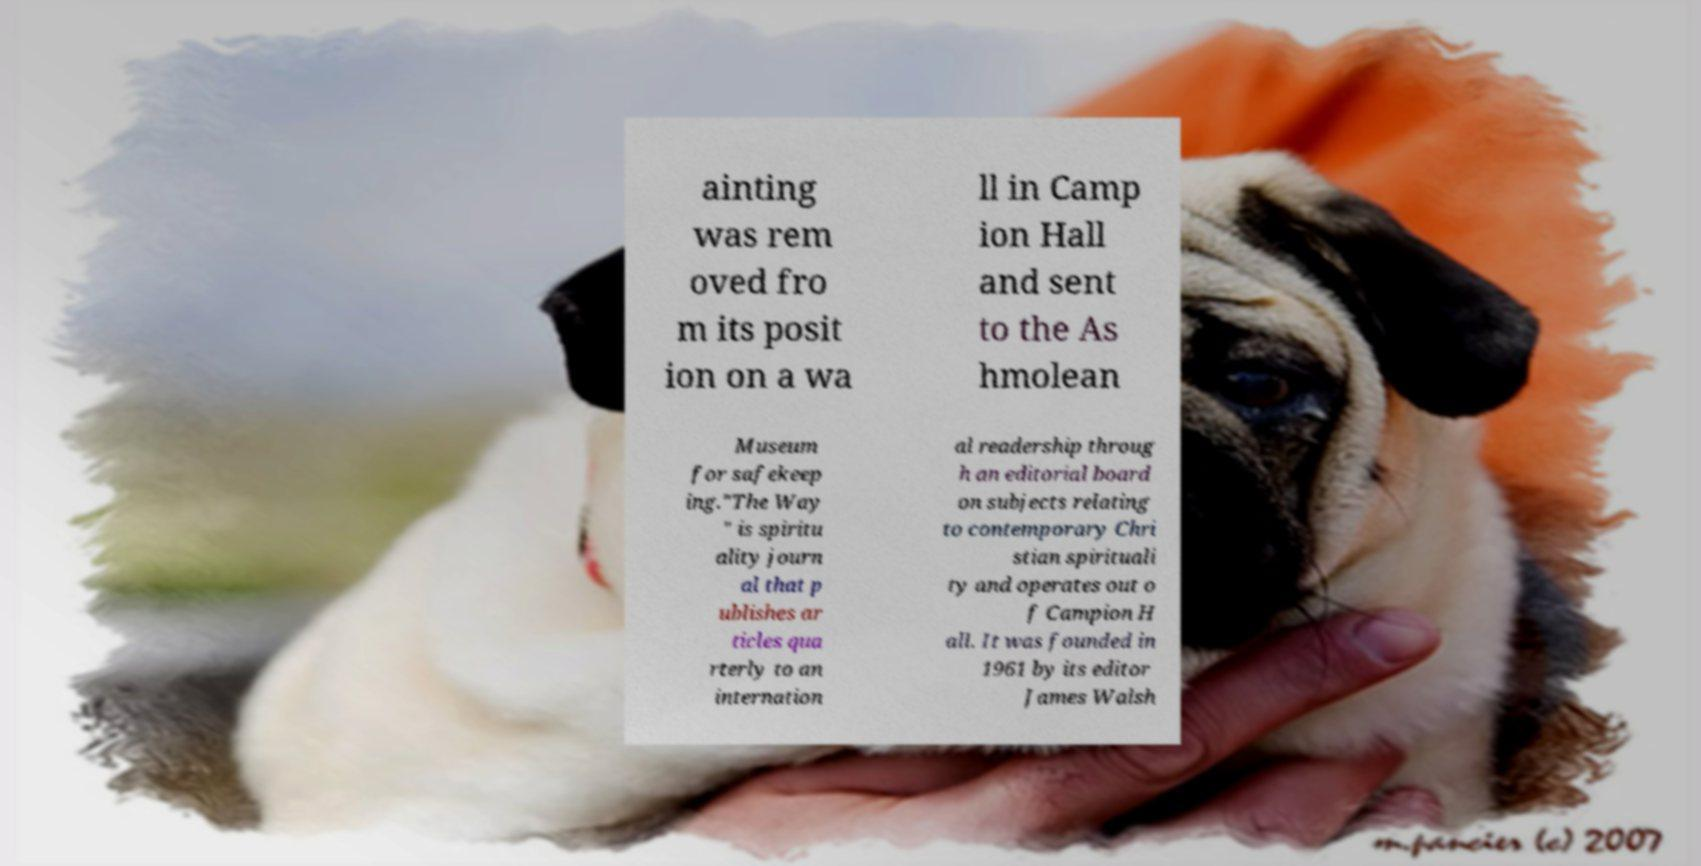Could you assist in decoding the text presented in this image and type it out clearly? ainting was rem oved fro m its posit ion on a wa ll in Camp ion Hall and sent to the As hmolean Museum for safekeep ing."The Way " is spiritu ality journ al that p ublishes ar ticles qua rterly to an internation al readership throug h an editorial board on subjects relating to contemporary Chri stian spirituali ty and operates out o f Campion H all. It was founded in 1961 by its editor James Walsh 